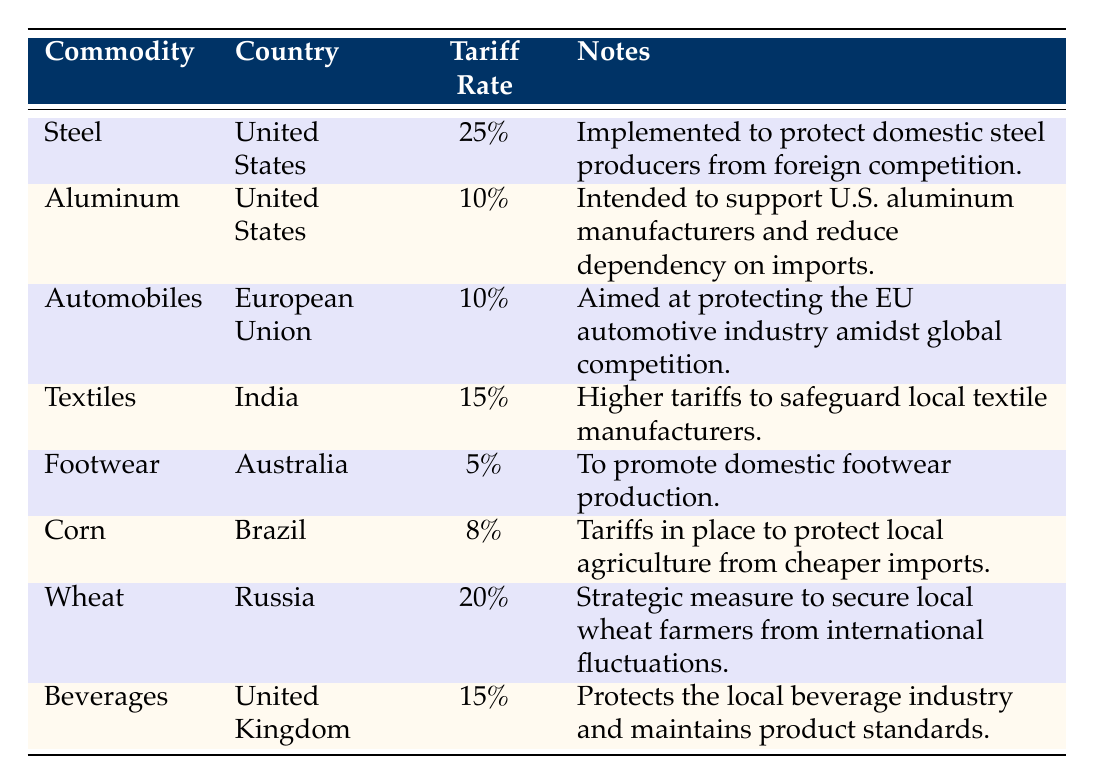What is the tariff rate on Steel in the United States? The table shows that the tariff rate on Steel in the United States is specified as 25%.
Answer: 25% What commodity has the highest tariff rate? By examining the tariff rates listed, Steel has the highest tariff rate at 25%.
Answer: Steel Is there a tariff on Aluminum in the United States? Yes, the table confirms that there is a tariff on Aluminum in the United States at a rate of 10%.
Answer: Yes Which country has a 20% tariff rate, and what commodity does it apply to? The table lists a 20% tariff rate for Wheat, applicable to Russia.
Answer: Russia, Wheat What is the average tariff rate for the commodities listed from the United States? The tariff rates for the United States are 25% (Steel) and 10% (Aluminum). The sum is 25 + 10 = 35%, and there are 2 commodities, so the average is 35/2 = 17.5%.
Answer: 17.5% Which commodity has the lowest tariff rate and what is that rate? By reviewing the table, Footwear has the lowest tariff rate of 5%.
Answer: Footwear, 5% Does India have a higher tariff on Textiles than the European Union has on Automobiles? The tariff on Textiles in India is 15%, while the tariff on Automobiles in the European Union is 10%. Since 15% is greater than 10%, the answer is yes.
Answer: Yes If the tariff rate on Wheat were to increase by 5%, what would the new rate be? The current tariff rate on Wheat is 20%. Adding 5% results in a new rate of 25%.
Answer: 25% What percentage of tariff is imposed on Beverages in the United Kingdom? The tariff rate for Beverages in the United Kingdom is noted in the table as 15%.
Answer: 15% 